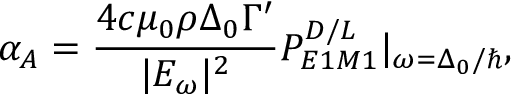Convert formula to latex. <formula><loc_0><loc_0><loc_500><loc_500>\alpha _ { A } = \frac { 4 c \mu _ { 0 } \rho \Delta _ { 0 } \Gamma ^ { \prime } } { | E _ { \omega } | ^ { 2 } } P _ { E 1 M 1 } ^ { D / L } | _ { \omega = \Delta _ { 0 } / } ,</formula> 